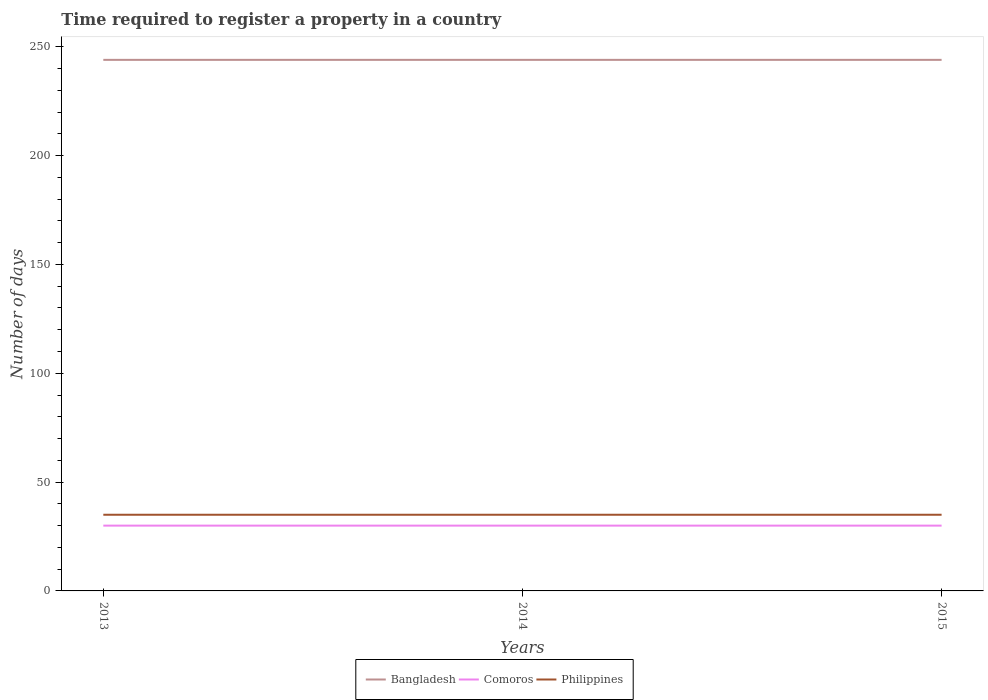How many different coloured lines are there?
Provide a succinct answer. 3. Across all years, what is the maximum number of days required to register a property in Comoros?
Offer a very short reply. 30. What is the difference between the highest and the second highest number of days required to register a property in Philippines?
Make the answer very short. 0. What is the difference between the highest and the lowest number of days required to register a property in Comoros?
Give a very brief answer. 0. Is the number of days required to register a property in Bangladesh strictly greater than the number of days required to register a property in Philippines over the years?
Give a very brief answer. No. How many lines are there?
Offer a very short reply. 3. How many years are there in the graph?
Offer a very short reply. 3. Are the values on the major ticks of Y-axis written in scientific E-notation?
Keep it short and to the point. No. Where does the legend appear in the graph?
Provide a short and direct response. Bottom center. How are the legend labels stacked?
Your response must be concise. Horizontal. What is the title of the graph?
Provide a short and direct response. Time required to register a property in a country. What is the label or title of the X-axis?
Make the answer very short. Years. What is the label or title of the Y-axis?
Ensure brevity in your answer.  Number of days. What is the Number of days of Bangladesh in 2013?
Your answer should be very brief. 244. What is the Number of days of Bangladesh in 2014?
Your answer should be very brief. 244. What is the Number of days in Philippines in 2014?
Offer a very short reply. 35. What is the Number of days in Bangladesh in 2015?
Your answer should be compact. 244. What is the Number of days of Comoros in 2015?
Give a very brief answer. 30. Across all years, what is the maximum Number of days in Bangladesh?
Your response must be concise. 244. Across all years, what is the maximum Number of days in Comoros?
Keep it short and to the point. 30. Across all years, what is the maximum Number of days in Philippines?
Ensure brevity in your answer.  35. Across all years, what is the minimum Number of days in Bangladesh?
Offer a very short reply. 244. Across all years, what is the minimum Number of days in Comoros?
Your response must be concise. 30. Across all years, what is the minimum Number of days of Philippines?
Your response must be concise. 35. What is the total Number of days in Bangladesh in the graph?
Provide a succinct answer. 732. What is the total Number of days in Comoros in the graph?
Provide a short and direct response. 90. What is the total Number of days in Philippines in the graph?
Offer a terse response. 105. What is the difference between the Number of days of Bangladesh in 2013 and that in 2014?
Give a very brief answer. 0. What is the difference between the Number of days in Comoros in 2013 and that in 2014?
Make the answer very short. 0. What is the difference between the Number of days of Philippines in 2013 and that in 2014?
Ensure brevity in your answer.  0. What is the difference between the Number of days in Bangladesh in 2013 and that in 2015?
Provide a succinct answer. 0. What is the difference between the Number of days of Bangladesh in 2013 and the Number of days of Comoros in 2014?
Offer a terse response. 214. What is the difference between the Number of days in Bangladesh in 2013 and the Number of days in Philippines in 2014?
Provide a short and direct response. 209. What is the difference between the Number of days of Comoros in 2013 and the Number of days of Philippines in 2014?
Make the answer very short. -5. What is the difference between the Number of days of Bangladesh in 2013 and the Number of days of Comoros in 2015?
Your answer should be very brief. 214. What is the difference between the Number of days in Bangladesh in 2013 and the Number of days in Philippines in 2015?
Offer a very short reply. 209. What is the difference between the Number of days in Comoros in 2013 and the Number of days in Philippines in 2015?
Your answer should be compact. -5. What is the difference between the Number of days of Bangladesh in 2014 and the Number of days of Comoros in 2015?
Your answer should be compact. 214. What is the difference between the Number of days of Bangladesh in 2014 and the Number of days of Philippines in 2015?
Offer a terse response. 209. What is the difference between the Number of days of Comoros in 2014 and the Number of days of Philippines in 2015?
Provide a succinct answer. -5. What is the average Number of days of Bangladesh per year?
Provide a succinct answer. 244. What is the average Number of days of Comoros per year?
Provide a short and direct response. 30. What is the average Number of days of Philippines per year?
Offer a terse response. 35. In the year 2013, what is the difference between the Number of days in Bangladesh and Number of days in Comoros?
Make the answer very short. 214. In the year 2013, what is the difference between the Number of days of Bangladesh and Number of days of Philippines?
Your answer should be compact. 209. In the year 2014, what is the difference between the Number of days of Bangladesh and Number of days of Comoros?
Provide a succinct answer. 214. In the year 2014, what is the difference between the Number of days of Bangladesh and Number of days of Philippines?
Make the answer very short. 209. In the year 2014, what is the difference between the Number of days of Comoros and Number of days of Philippines?
Give a very brief answer. -5. In the year 2015, what is the difference between the Number of days of Bangladesh and Number of days of Comoros?
Provide a succinct answer. 214. In the year 2015, what is the difference between the Number of days in Bangladesh and Number of days in Philippines?
Ensure brevity in your answer.  209. In the year 2015, what is the difference between the Number of days of Comoros and Number of days of Philippines?
Ensure brevity in your answer.  -5. What is the ratio of the Number of days in Bangladesh in 2013 to that in 2014?
Make the answer very short. 1. What is the ratio of the Number of days of Comoros in 2013 to that in 2014?
Keep it short and to the point. 1. What is the ratio of the Number of days of Comoros in 2013 to that in 2015?
Give a very brief answer. 1. What is the ratio of the Number of days in Bangladesh in 2014 to that in 2015?
Offer a terse response. 1. What is the ratio of the Number of days of Philippines in 2014 to that in 2015?
Offer a terse response. 1. What is the difference between the highest and the second highest Number of days in Philippines?
Ensure brevity in your answer.  0. 